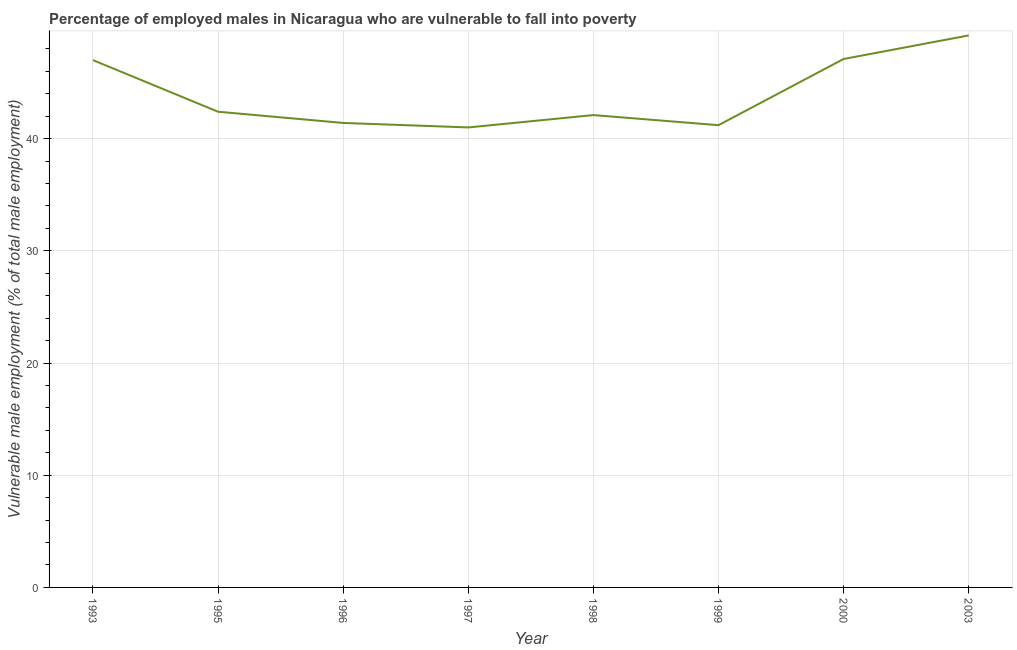What is the percentage of employed males who are vulnerable to fall into poverty in 1996?
Provide a short and direct response. 41.4. Across all years, what is the maximum percentage of employed males who are vulnerable to fall into poverty?
Provide a succinct answer. 49.2. In which year was the percentage of employed males who are vulnerable to fall into poverty maximum?
Your answer should be compact. 2003. In which year was the percentage of employed males who are vulnerable to fall into poverty minimum?
Your answer should be very brief. 1997. What is the sum of the percentage of employed males who are vulnerable to fall into poverty?
Provide a succinct answer. 351.4. What is the average percentage of employed males who are vulnerable to fall into poverty per year?
Keep it short and to the point. 43.93. What is the median percentage of employed males who are vulnerable to fall into poverty?
Your response must be concise. 42.25. Do a majority of the years between 1998 and 1997 (inclusive) have percentage of employed males who are vulnerable to fall into poverty greater than 2 %?
Provide a succinct answer. No. What is the ratio of the percentage of employed males who are vulnerable to fall into poverty in 1999 to that in 2003?
Offer a very short reply. 0.84. Is the percentage of employed males who are vulnerable to fall into poverty in 2000 less than that in 2003?
Offer a terse response. Yes. Is the difference between the percentage of employed males who are vulnerable to fall into poverty in 1999 and 2000 greater than the difference between any two years?
Ensure brevity in your answer.  No. What is the difference between the highest and the second highest percentage of employed males who are vulnerable to fall into poverty?
Your response must be concise. 2.1. Is the sum of the percentage of employed males who are vulnerable to fall into poverty in 1993 and 1998 greater than the maximum percentage of employed males who are vulnerable to fall into poverty across all years?
Your response must be concise. Yes. What is the difference between the highest and the lowest percentage of employed males who are vulnerable to fall into poverty?
Offer a very short reply. 8.2. In how many years, is the percentage of employed males who are vulnerable to fall into poverty greater than the average percentage of employed males who are vulnerable to fall into poverty taken over all years?
Make the answer very short. 3. How many lines are there?
Provide a succinct answer. 1. Does the graph contain any zero values?
Your answer should be compact. No. What is the title of the graph?
Provide a succinct answer. Percentage of employed males in Nicaragua who are vulnerable to fall into poverty. What is the label or title of the X-axis?
Provide a short and direct response. Year. What is the label or title of the Y-axis?
Your answer should be very brief. Vulnerable male employment (% of total male employment). What is the Vulnerable male employment (% of total male employment) in 1995?
Provide a succinct answer. 42.4. What is the Vulnerable male employment (% of total male employment) in 1996?
Keep it short and to the point. 41.4. What is the Vulnerable male employment (% of total male employment) of 1998?
Offer a very short reply. 42.1. What is the Vulnerable male employment (% of total male employment) of 1999?
Keep it short and to the point. 41.2. What is the Vulnerable male employment (% of total male employment) in 2000?
Your answer should be very brief. 47.1. What is the Vulnerable male employment (% of total male employment) of 2003?
Give a very brief answer. 49.2. What is the difference between the Vulnerable male employment (% of total male employment) in 1993 and 2003?
Your answer should be very brief. -2.2. What is the difference between the Vulnerable male employment (% of total male employment) in 1995 and 1996?
Keep it short and to the point. 1. What is the difference between the Vulnerable male employment (% of total male employment) in 1995 and 1999?
Offer a very short reply. 1.2. What is the difference between the Vulnerable male employment (% of total male employment) in 1995 and 2000?
Offer a very short reply. -4.7. What is the difference between the Vulnerable male employment (% of total male employment) in 1996 and 1999?
Your response must be concise. 0.2. What is the difference between the Vulnerable male employment (% of total male employment) in 1996 and 2000?
Offer a terse response. -5.7. What is the difference between the Vulnerable male employment (% of total male employment) in 1996 and 2003?
Your response must be concise. -7.8. What is the difference between the Vulnerable male employment (% of total male employment) in 1997 and 1999?
Your response must be concise. -0.2. What is the difference between the Vulnerable male employment (% of total male employment) in 1997 and 2000?
Keep it short and to the point. -6.1. What is the ratio of the Vulnerable male employment (% of total male employment) in 1993 to that in 1995?
Your response must be concise. 1.11. What is the ratio of the Vulnerable male employment (% of total male employment) in 1993 to that in 1996?
Provide a succinct answer. 1.14. What is the ratio of the Vulnerable male employment (% of total male employment) in 1993 to that in 1997?
Your answer should be very brief. 1.15. What is the ratio of the Vulnerable male employment (% of total male employment) in 1993 to that in 1998?
Keep it short and to the point. 1.12. What is the ratio of the Vulnerable male employment (% of total male employment) in 1993 to that in 1999?
Keep it short and to the point. 1.14. What is the ratio of the Vulnerable male employment (% of total male employment) in 1993 to that in 2003?
Keep it short and to the point. 0.95. What is the ratio of the Vulnerable male employment (% of total male employment) in 1995 to that in 1997?
Keep it short and to the point. 1.03. What is the ratio of the Vulnerable male employment (% of total male employment) in 1995 to that in 1998?
Offer a terse response. 1.01. What is the ratio of the Vulnerable male employment (% of total male employment) in 1995 to that in 2003?
Your answer should be compact. 0.86. What is the ratio of the Vulnerable male employment (% of total male employment) in 1996 to that in 1998?
Make the answer very short. 0.98. What is the ratio of the Vulnerable male employment (% of total male employment) in 1996 to that in 2000?
Provide a short and direct response. 0.88. What is the ratio of the Vulnerable male employment (% of total male employment) in 1996 to that in 2003?
Provide a short and direct response. 0.84. What is the ratio of the Vulnerable male employment (% of total male employment) in 1997 to that in 1998?
Ensure brevity in your answer.  0.97. What is the ratio of the Vulnerable male employment (% of total male employment) in 1997 to that in 2000?
Your answer should be very brief. 0.87. What is the ratio of the Vulnerable male employment (% of total male employment) in 1997 to that in 2003?
Your response must be concise. 0.83. What is the ratio of the Vulnerable male employment (% of total male employment) in 1998 to that in 1999?
Ensure brevity in your answer.  1.02. What is the ratio of the Vulnerable male employment (% of total male employment) in 1998 to that in 2000?
Your answer should be very brief. 0.89. What is the ratio of the Vulnerable male employment (% of total male employment) in 1998 to that in 2003?
Offer a very short reply. 0.86. What is the ratio of the Vulnerable male employment (% of total male employment) in 1999 to that in 2000?
Your answer should be very brief. 0.88. What is the ratio of the Vulnerable male employment (% of total male employment) in 1999 to that in 2003?
Keep it short and to the point. 0.84. 